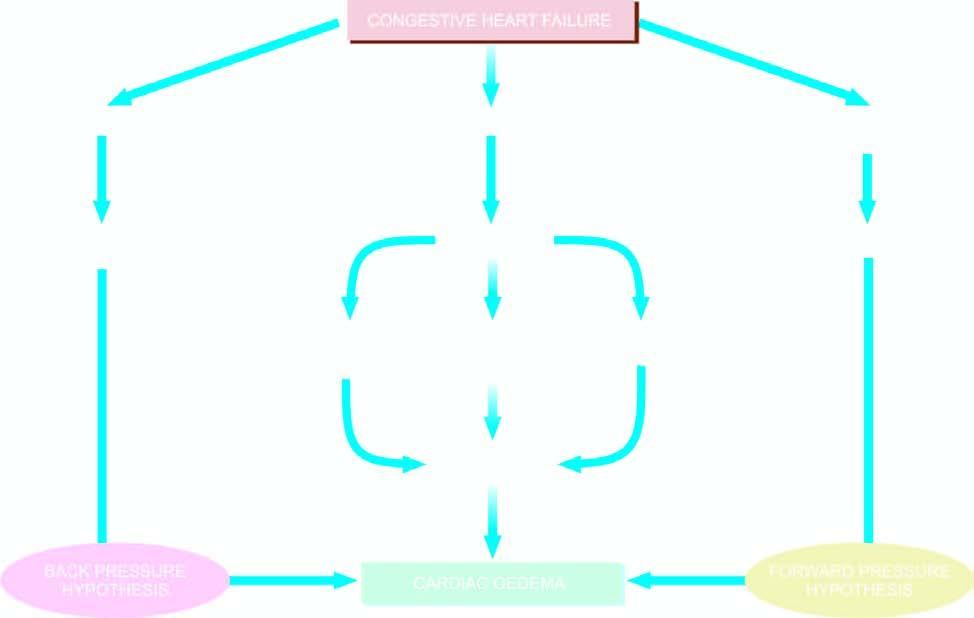s c, x-ray crystallography and infra-red spectroscopy involved in the pathogenesis of cardiac oedema?
Answer the question using a single word or phrase. No 